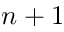Convert formula to latex. <formula><loc_0><loc_0><loc_500><loc_500>n + 1</formula> 